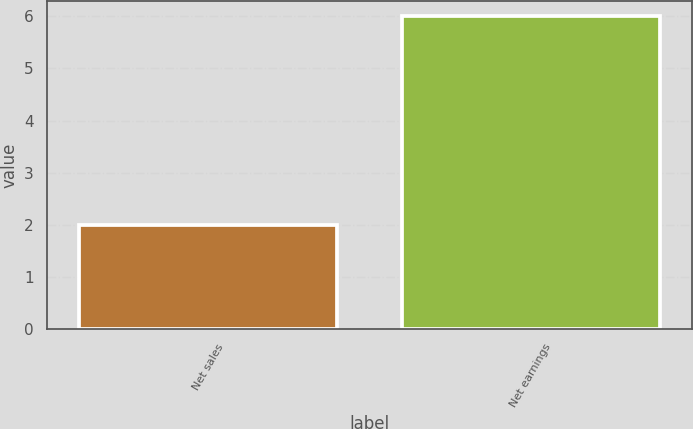Convert chart to OTSL. <chart><loc_0><loc_0><loc_500><loc_500><bar_chart><fcel>Net sales<fcel>Net earnings<nl><fcel>2<fcel>6<nl></chart> 